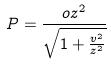Convert formula to latex. <formula><loc_0><loc_0><loc_500><loc_500>P = \frac { o z ^ { 2 } } { \sqrt { 1 + \frac { v ^ { 2 } } { z ^ { 2 } } } }</formula> 